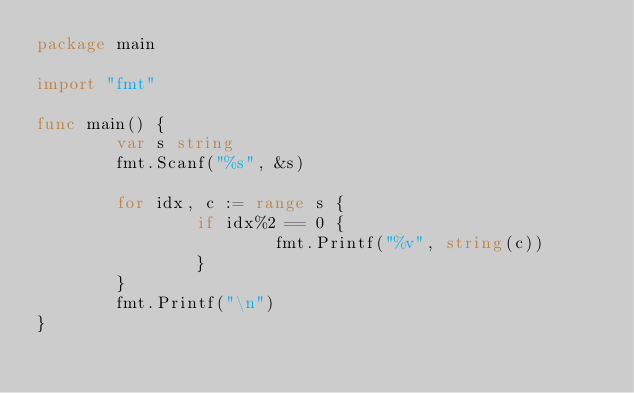<code> <loc_0><loc_0><loc_500><loc_500><_Go_>package main

import "fmt"

func main() {
        var s string
        fmt.Scanf("%s", &s)

        for idx, c := range s {
                if idx%2 == 0 {
                        fmt.Printf("%v", string(c))
                }
        }
        fmt.Printf("\n")
}</code> 